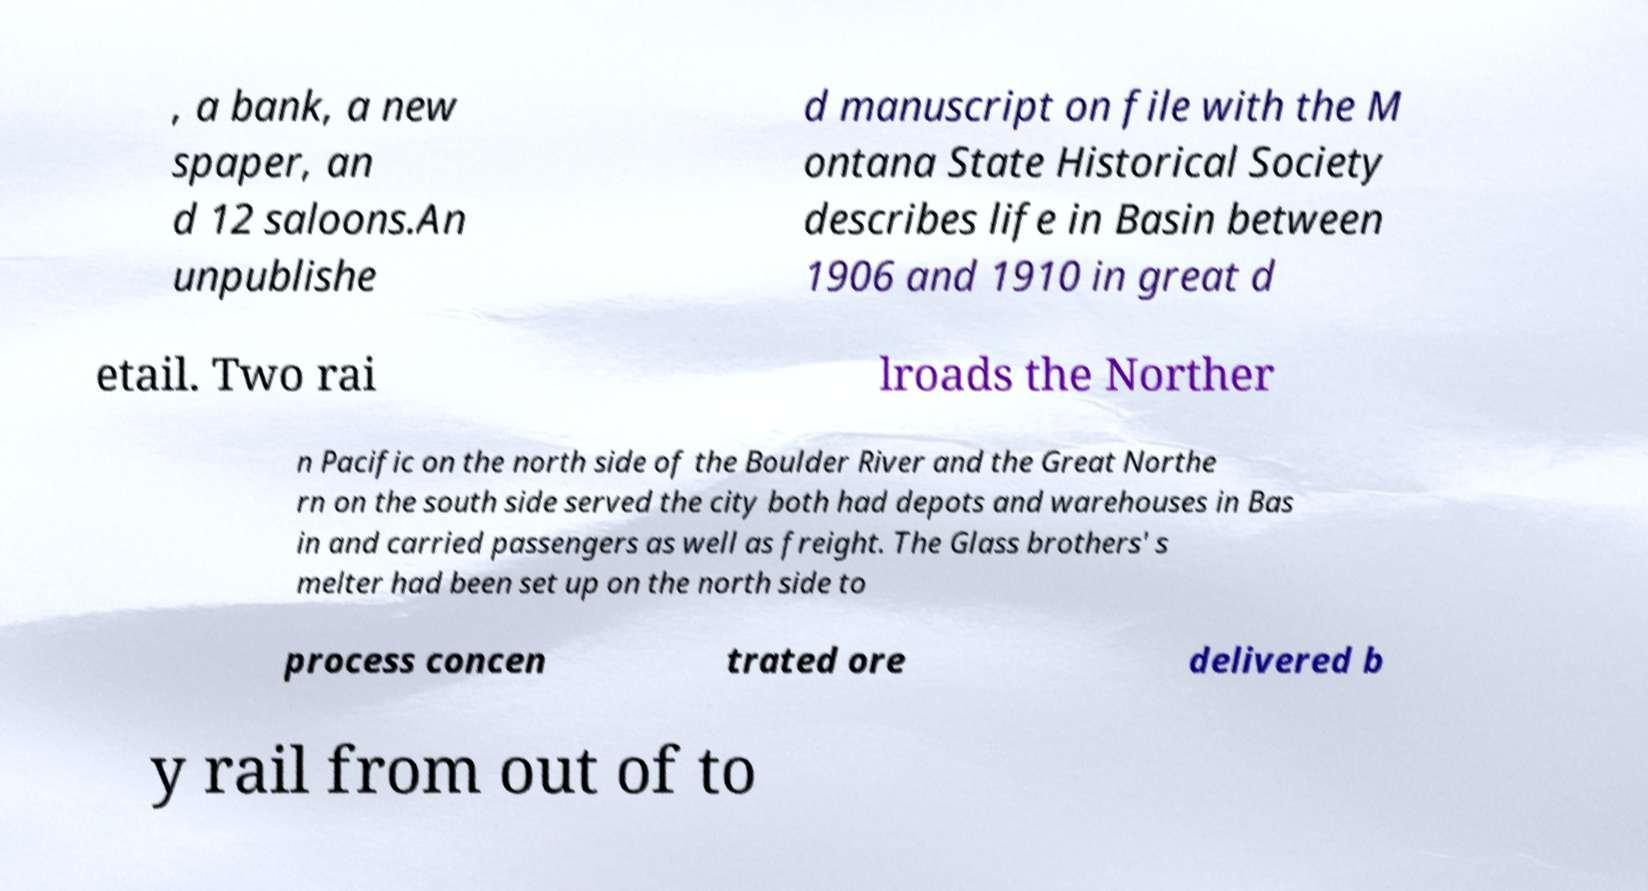What messages or text are displayed in this image? I need them in a readable, typed format. , a bank, a new spaper, an d 12 saloons.An unpublishe d manuscript on file with the M ontana State Historical Society describes life in Basin between 1906 and 1910 in great d etail. Two rai lroads the Norther n Pacific on the north side of the Boulder River and the Great Northe rn on the south side served the city both had depots and warehouses in Bas in and carried passengers as well as freight. The Glass brothers' s melter had been set up on the north side to process concen trated ore delivered b y rail from out of to 